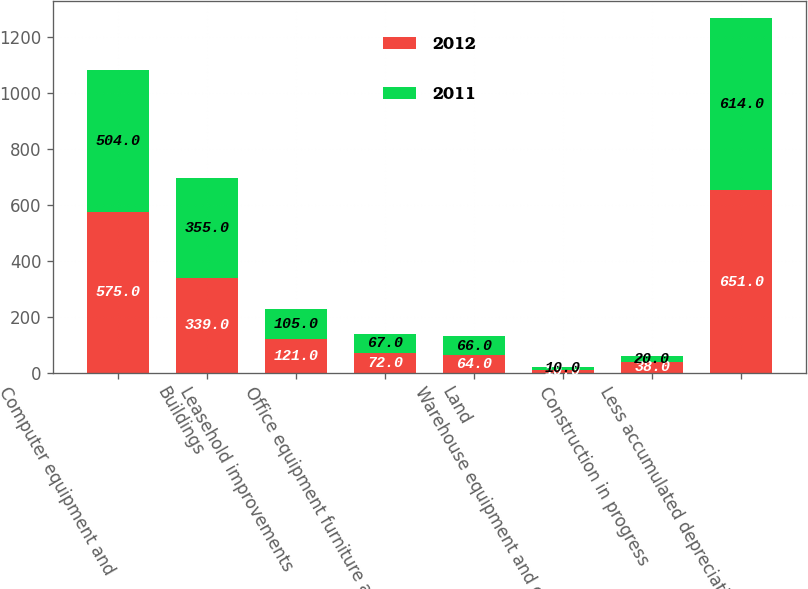Convert chart to OTSL. <chart><loc_0><loc_0><loc_500><loc_500><stacked_bar_chart><ecel><fcel>Computer equipment and<fcel>Buildings<fcel>Leasehold improvements<fcel>Office equipment furniture and<fcel>Land<fcel>Warehouse equipment and other<fcel>Construction in progress<fcel>Less accumulated depreciation<nl><fcel>2012<fcel>575<fcel>339<fcel>121<fcel>72<fcel>64<fcel>10<fcel>38<fcel>651<nl><fcel>2011<fcel>504<fcel>355<fcel>105<fcel>67<fcel>66<fcel>10<fcel>20<fcel>614<nl></chart> 